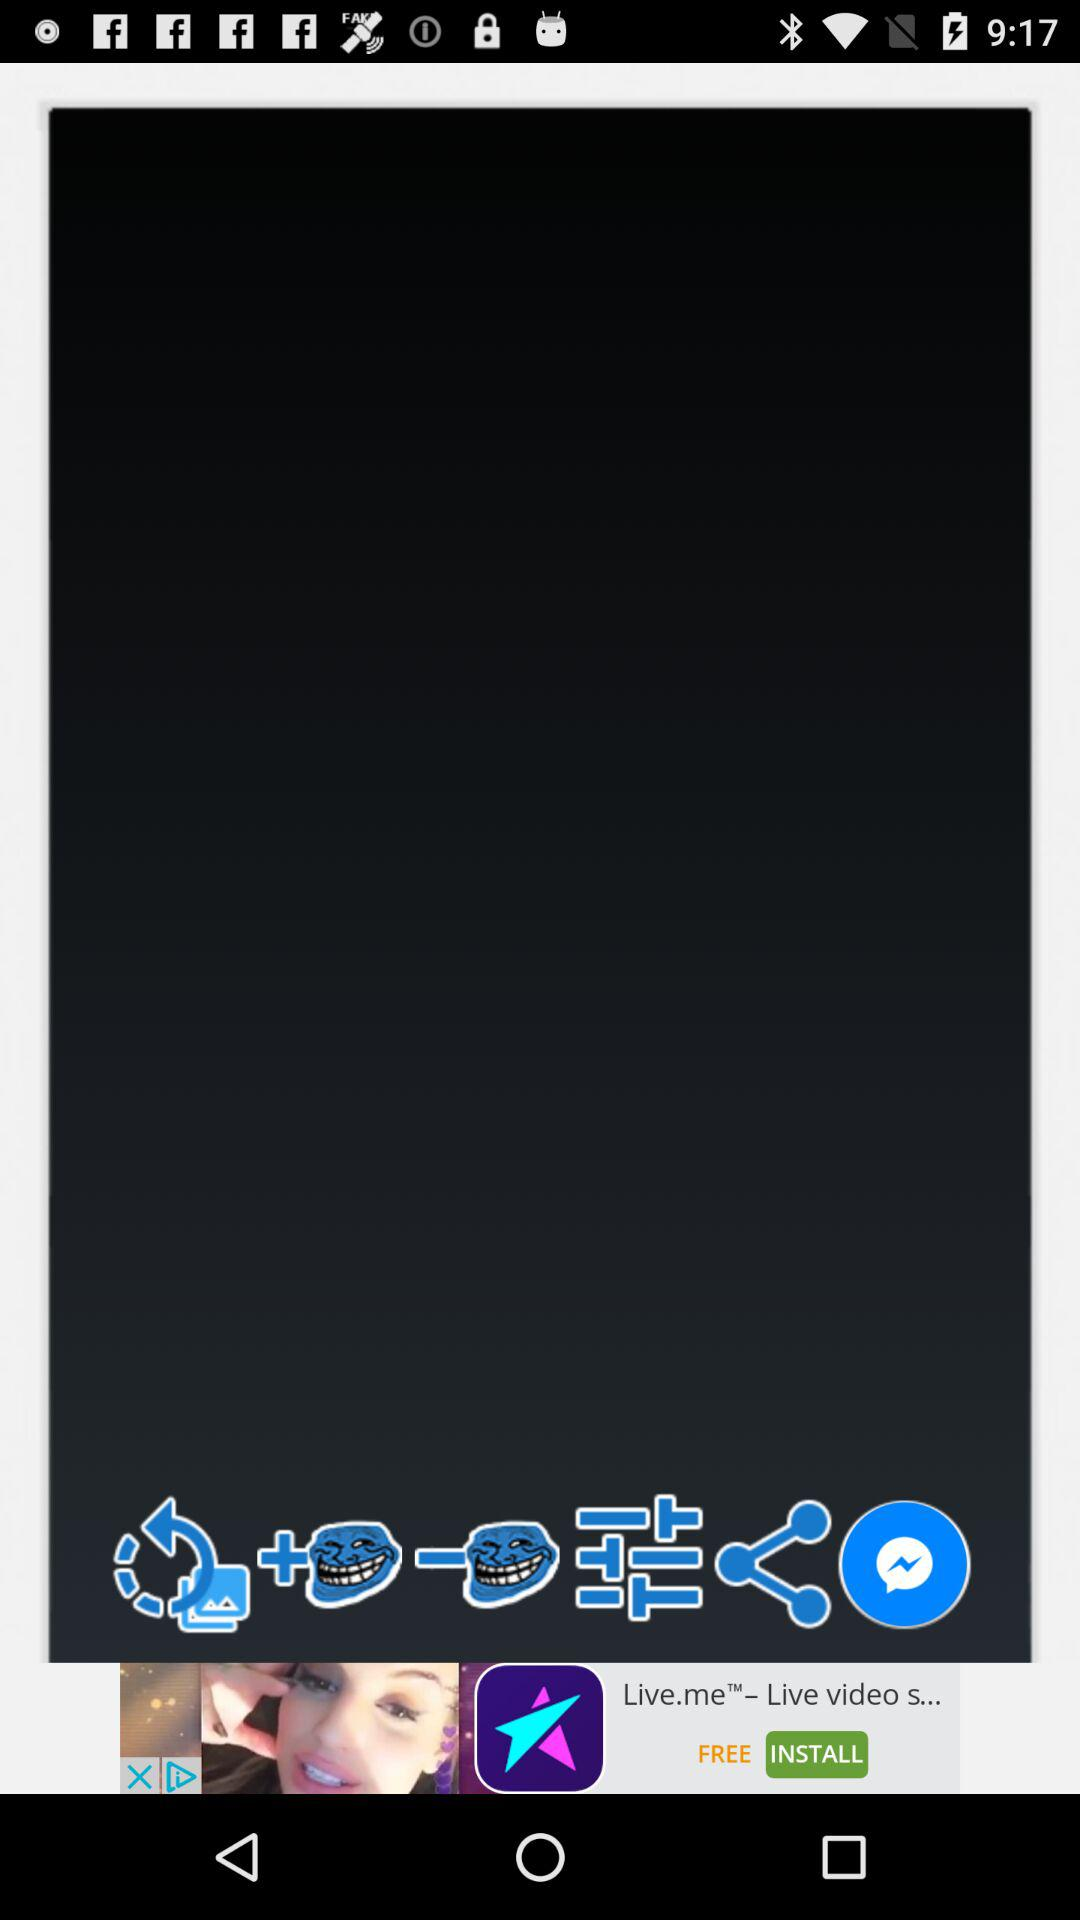How many troll face stickers are there?
Answer the question using a single word or phrase. 2 